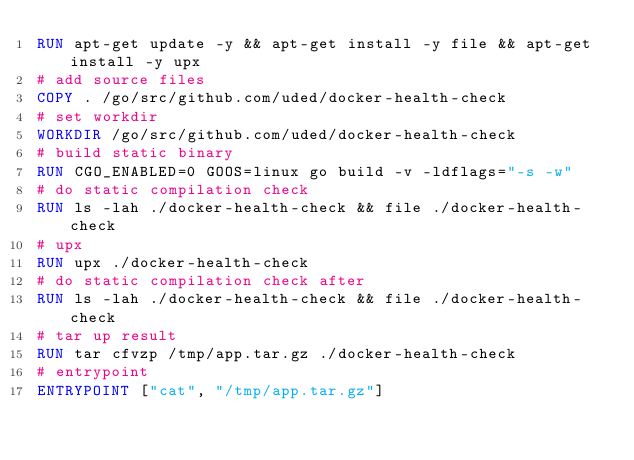Convert code to text. <code><loc_0><loc_0><loc_500><loc_500><_Dockerfile_>RUN apt-get update -y && apt-get install -y file && apt-get install -y upx
# add source files
COPY . /go/src/github.com/uded/docker-health-check
# set workdir
WORKDIR /go/src/github.com/uded/docker-health-check
# build static binary
RUN CGO_ENABLED=0 GOOS=linux go build -v -ldflags="-s -w"
# do static compilation check
RUN ls -lah ./docker-health-check && file ./docker-health-check
# upx
RUN upx ./docker-health-check
# do static compilation check after
RUN ls -lah ./docker-health-check && file ./docker-health-check
# tar up result
RUN tar cfvzp /tmp/app.tar.gz ./docker-health-check
# entrypoint
ENTRYPOINT ["cat", "/tmp/app.tar.gz"]
</code> 